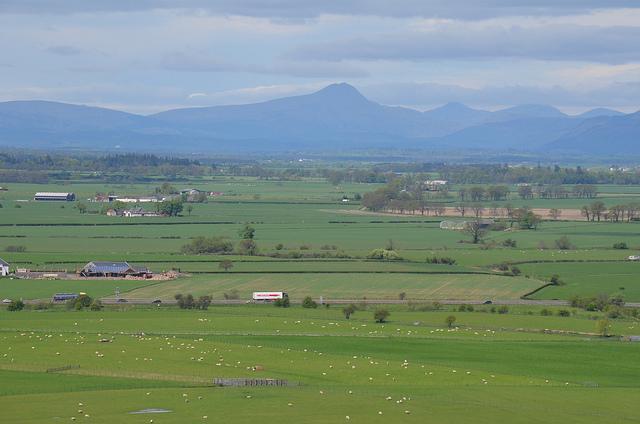How many sheep are there?
Give a very brief answer. 1. 